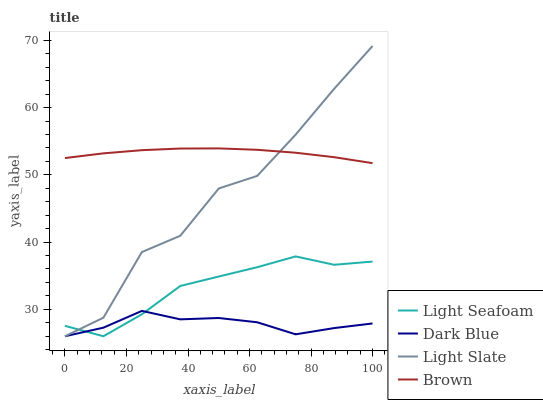Does Dark Blue have the minimum area under the curve?
Answer yes or no. Yes. Does Brown have the maximum area under the curve?
Answer yes or no. Yes. Does Light Seafoam have the minimum area under the curve?
Answer yes or no. No. Does Light Seafoam have the maximum area under the curve?
Answer yes or no. No. Is Brown the smoothest?
Answer yes or no. Yes. Is Light Slate the roughest?
Answer yes or no. Yes. Is Dark Blue the smoothest?
Answer yes or no. No. Is Dark Blue the roughest?
Answer yes or no. No. Does Brown have the lowest value?
Answer yes or no. No. Does Light Seafoam have the highest value?
Answer yes or no. No. Is Dark Blue less than Brown?
Answer yes or no. Yes. Is Brown greater than Light Seafoam?
Answer yes or no. Yes. Does Dark Blue intersect Brown?
Answer yes or no. No. 